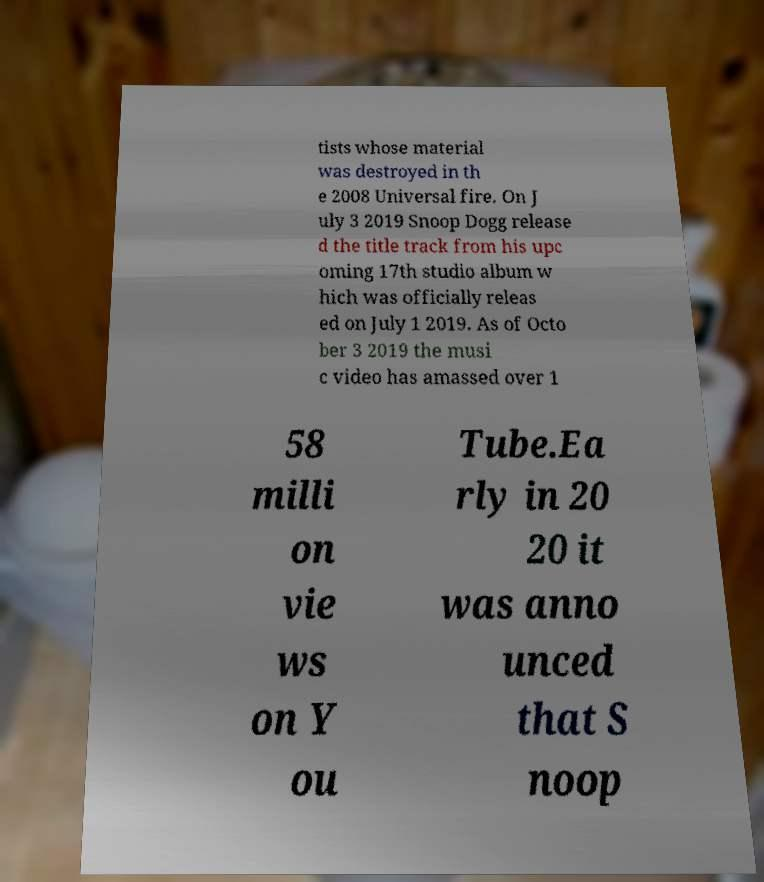I need the written content from this picture converted into text. Can you do that? tists whose material was destroyed in th e 2008 Universal fire. On J uly 3 2019 Snoop Dogg release d the title track from his upc oming 17th studio album w hich was officially releas ed on July 1 2019. As of Octo ber 3 2019 the musi c video has amassed over 1 58 milli on vie ws on Y ou Tube.Ea rly in 20 20 it was anno unced that S noop 